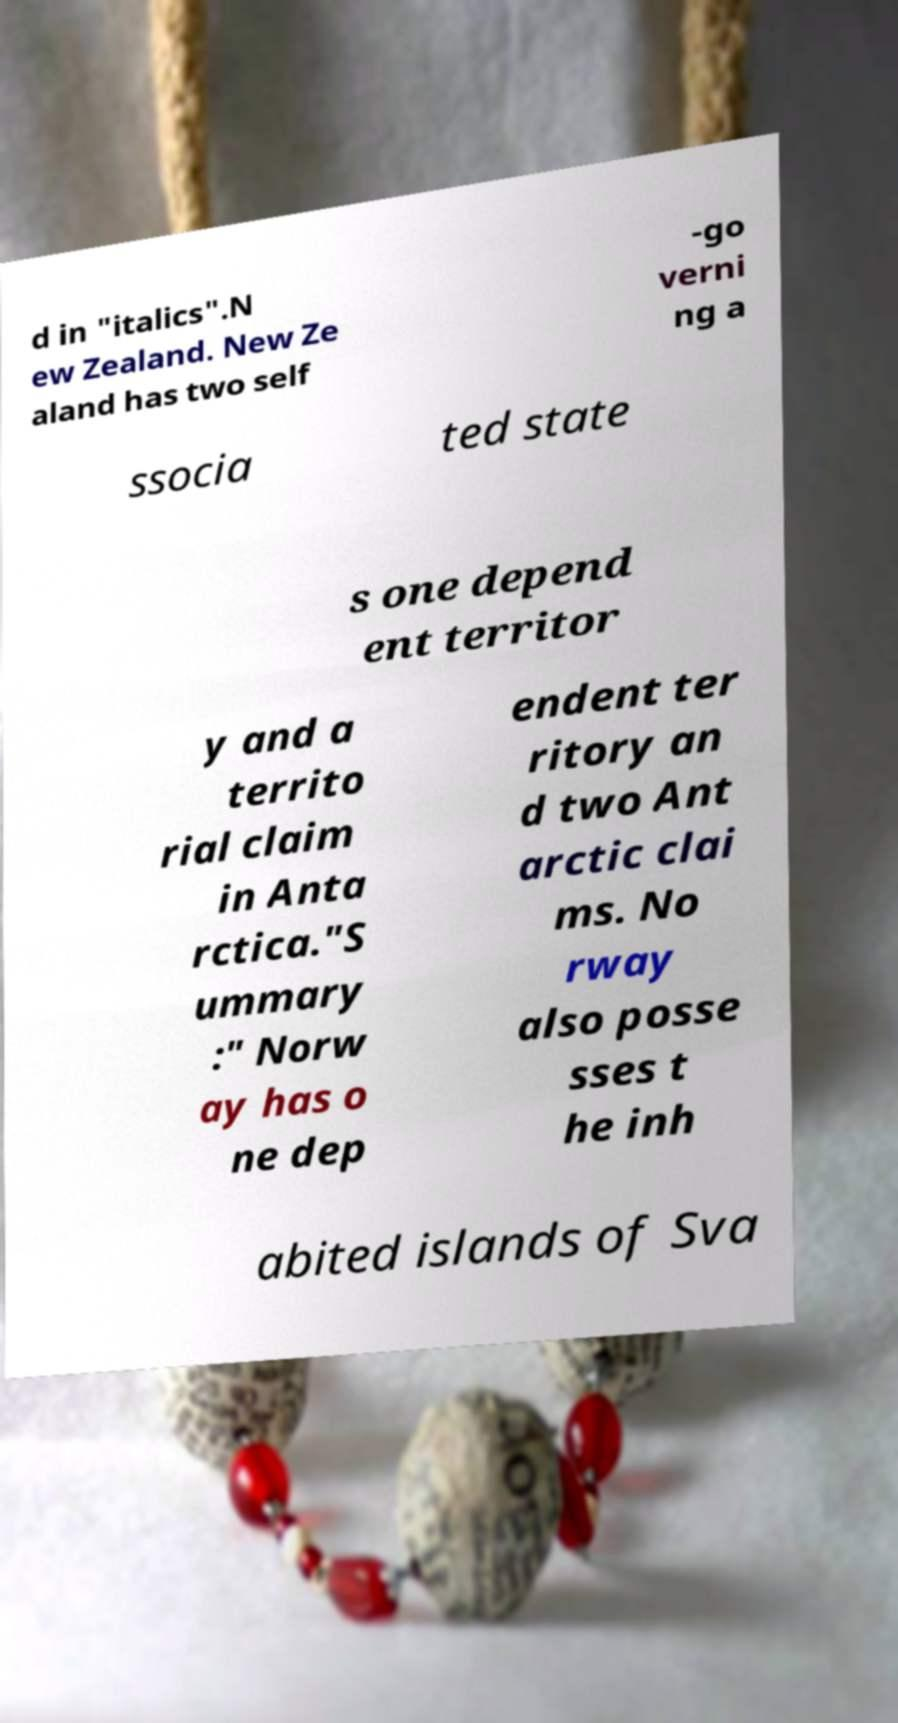I need the written content from this picture converted into text. Can you do that? d in "italics".N ew Zealand. New Ze aland has two self -go verni ng a ssocia ted state s one depend ent territor y and a territo rial claim in Anta rctica."S ummary :" Norw ay has o ne dep endent ter ritory an d two Ant arctic clai ms. No rway also posse sses t he inh abited islands of Sva 